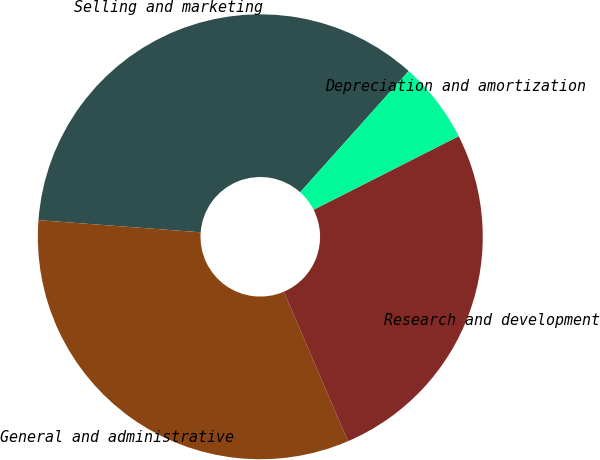Convert chart to OTSL. <chart><loc_0><loc_0><loc_500><loc_500><pie_chart><fcel>Selling and marketing<fcel>General and administrative<fcel>Research and development<fcel>Depreciation and amortization<nl><fcel>35.43%<fcel>32.64%<fcel>26.02%<fcel>5.91%<nl></chart> 